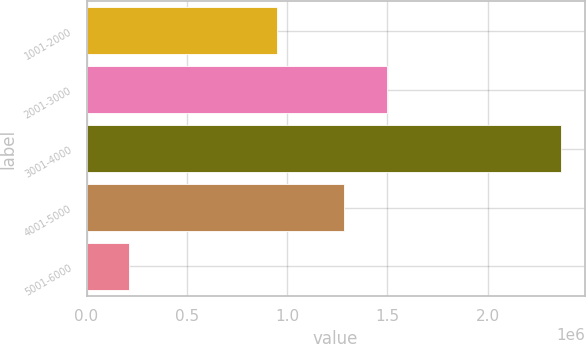<chart> <loc_0><loc_0><loc_500><loc_500><bar_chart><fcel>1001-2000<fcel>2001-3000<fcel>3001-4000<fcel>4001-5000<fcel>5001-6000<nl><fcel>948519<fcel>1.49931e+06<fcel>2.36496e+06<fcel>1.284e+06<fcel>211875<nl></chart> 